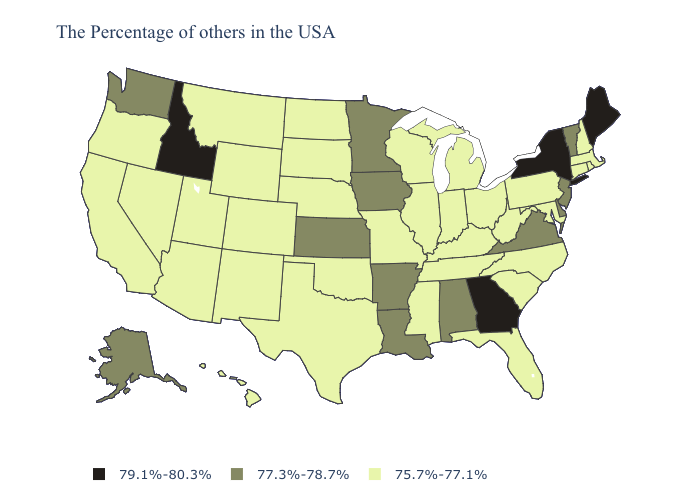Name the states that have a value in the range 79.1%-80.3%?
Quick response, please. Maine, New York, Georgia, Idaho. Name the states that have a value in the range 75.7%-77.1%?
Answer briefly. Massachusetts, Rhode Island, New Hampshire, Connecticut, Maryland, Pennsylvania, North Carolina, South Carolina, West Virginia, Ohio, Florida, Michigan, Kentucky, Indiana, Tennessee, Wisconsin, Illinois, Mississippi, Missouri, Nebraska, Oklahoma, Texas, South Dakota, North Dakota, Wyoming, Colorado, New Mexico, Utah, Montana, Arizona, Nevada, California, Oregon, Hawaii. What is the lowest value in the South?
Write a very short answer. 75.7%-77.1%. Name the states that have a value in the range 75.7%-77.1%?
Quick response, please. Massachusetts, Rhode Island, New Hampshire, Connecticut, Maryland, Pennsylvania, North Carolina, South Carolina, West Virginia, Ohio, Florida, Michigan, Kentucky, Indiana, Tennessee, Wisconsin, Illinois, Mississippi, Missouri, Nebraska, Oklahoma, Texas, South Dakota, North Dakota, Wyoming, Colorado, New Mexico, Utah, Montana, Arizona, Nevada, California, Oregon, Hawaii. Which states have the lowest value in the MidWest?
Keep it brief. Ohio, Michigan, Indiana, Wisconsin, Illinois, Missouri, Nebraska, South Dakota, North Dakota. What is the highest value in the MidWest ?
Quick response, please. 77.3%-78.7%. Name the states that have a value in the range 77.3%-78.7%?
Answer briefly. Vermont, New Jersey, Delaware, Virginia, Alabama, Louisiana, Arkansas, Minnesota, Iowa, Kansas, Washington, Alaska. Name the states that have a value in the range 75.7%-77.1%?
Answer briefly. Massachusetts, Rhode Island, New Hampshire, Connecticut, Maryland, Pennsylvania, North Carolina, South Carolina, West Virginia, Ohio, Florida, Michigan, Kentucky, Indiana, Tennessee, Wisconsin, Illinois, Mississippi, Missouri, Nebraska, Oklahoma, Texas, South Dakota, North Dakota, Wyoming, Colorado, New Mexico, Utah, Montana, Arizona, Nevada, California, Oregon, Hawaii. Does West Virginia have the highest value in the USA?
Be succinct. No. Name the states that have a value in the range 77.3%-78.7%?
Quick response, please. Vermont, New Jersey, Delaware, Virginia, Alabama, Louisiana, Arkansas, Minnesota, Iowa, Kansas, Washington, Alaska. Name the states that have a value in the range 77.3%-78.7%?
Quick response, please. Vermont, New Jersey, Delaware, Virginia, Alabama, Louisiana, Arkansas, Minnesota, Iowa, Kansas, Washington, Alaska. What is the value of Montana?
Quick response, please. 75.7%-77.1%. Which states have the lowest value in the MidWest?
Quick response, please. Ohio, Michigan, Indiana, Wisconsin, Illinois, Missouri, Nebraska, South Dakota, North Dakota. Is the legend a continuous bar?
Quick response, please. No. What is the lowest value in the South?
Concise answer only. 75.7%-77.1%. 